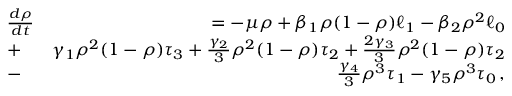Convert formula to latex. <formula><loc_0><loc_0><loc_500><loc_500>\begin{array} { r l r } & { \frac { d \rho } { d t } } & { = - \mu \rho + \beta _ { 1 } \rho ( 1 - \rho ) \ell _ { 1 } - \beta _ { 2 } \rho ^ { 2 } \ell _ { 0 } } \\ & { + } & { \gamma _ { 1 } \rho ^ { 2 } ( 1 - \rho ) \tau _ { 3 } + \frac { \gamma _ { 2 } } { 3 } \rho ^ { 2 } ( 1 - \rho ) \tau _ { 2 } + \frac { 2 \gamma _ { 3 } } { 3 } \rho ^ { 2 } ( 1 - \rho ) \tau _ { 2 } } \\ & { - } & { \frac { \gamma _ { 4 } } { 3 } \rho ^ { 3 } \tau _ { 1 } - \gamma _ { 5 } \rho ^ { 3 } \tau _ { 0 } \, , } \end{array}</formula> 